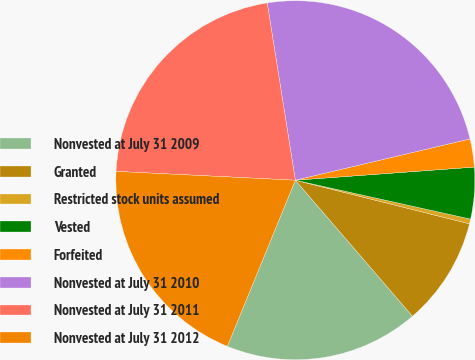Convert chart to OTSL. <chart><loc_0><loc_0><loc_500><loc_500><pie_chart><fcel>Nonvested at July 31 2009<fcel>Granted<fcel>Restricted stock units assumed<fcel>Vested<fcel>Forfeited<fcel>Nonvested at July 31 2010<fcel>Nonvested at July 31 2011<fcel>Nonvested at July 31 2012<nl><fcel>17.5%<fcel>9.78%<fcel>0.43%<fcel>4.64%<fcel>2.53%<fcel>23.81%<fcel>21.71%<fcel>19.6%<nl></chart> 